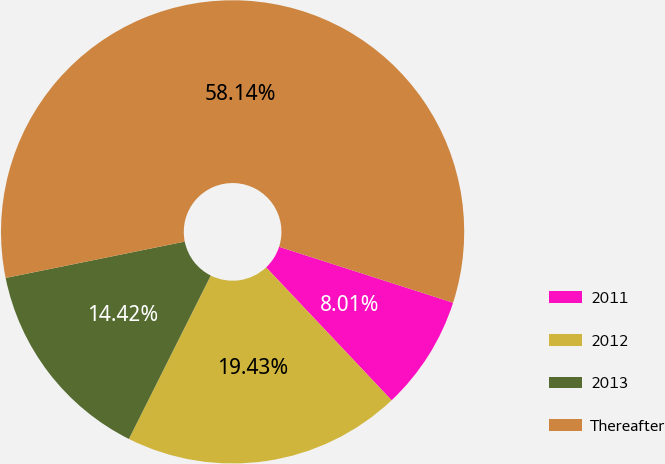<chart> <loc_0><loc_0><loc_500><loc_500><pie_chart><fcel>2011<fcel>2012<fcel>2013<fcel>Thereafter<nl><fcel>8.01%<fcel>19.43%<fcel>14.42%<fcel>58.13%<nl></chart> 